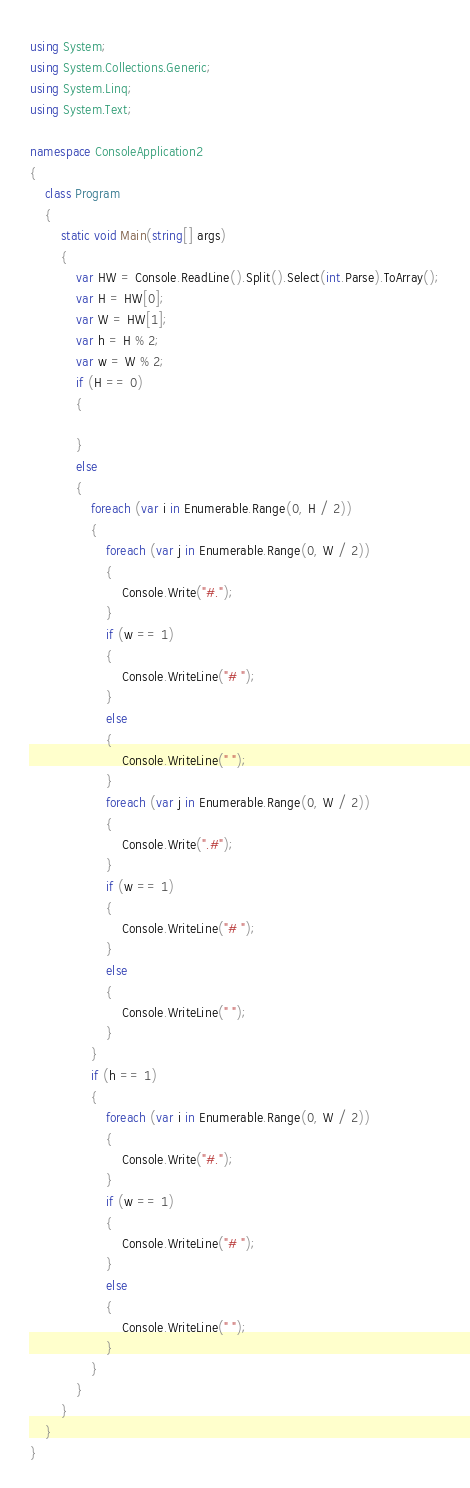<code> <loc_0><loc_0><loc_500><loc_500><_C#_>using System;
using System.Collections.Generic;
using System.Linq;
using System.Text;

namespace ConsoleApplication2
{
    class Program
    {
        static void Main(string[] args)
        {
            var HW = Console.ReadLine().Split().Select(int.Parse).ToArray();
            var H = HW[0];
            var W = HW[1];
            var h = H % 2;
            var w = W % 2;
            if (H == 0)
            {

            }
            else
            {
                foreach (var i in Enumerable.Range(0, H / 2))
                {
                    foreach (var j in Enumerable.Range(0, W / 2))
                    {
                        Console.Write("#.");
                    }
                    if (w == 1)
                    {
                        Console.WriteLine("# ");
                    }
                    else
                    {
                        Console.WriteLine(" ");
                    }
                    foreach (var j in Enumerable.Range(0, W / 2))
                    {
                        Console.Write(".#");
                    }
                    if (w == 1)
                    {
                        Console.WriteLine("# ");
                    }
                    else
                    {
                        Console.WriteLine(" ");
                    }
                }
                if (h == 1)
                {
                    foreach (var i in Enumerable.Range(0, W / 2))
                    {
                        Console.Write("#.");
                    }
                    if (w == 1)
                    {
                        Console.WriteLine("# ");
                    }
                    else
                    {
                        Console.WriteLine(" ");
                    }
                }
            }
        }
    }
}</code> 